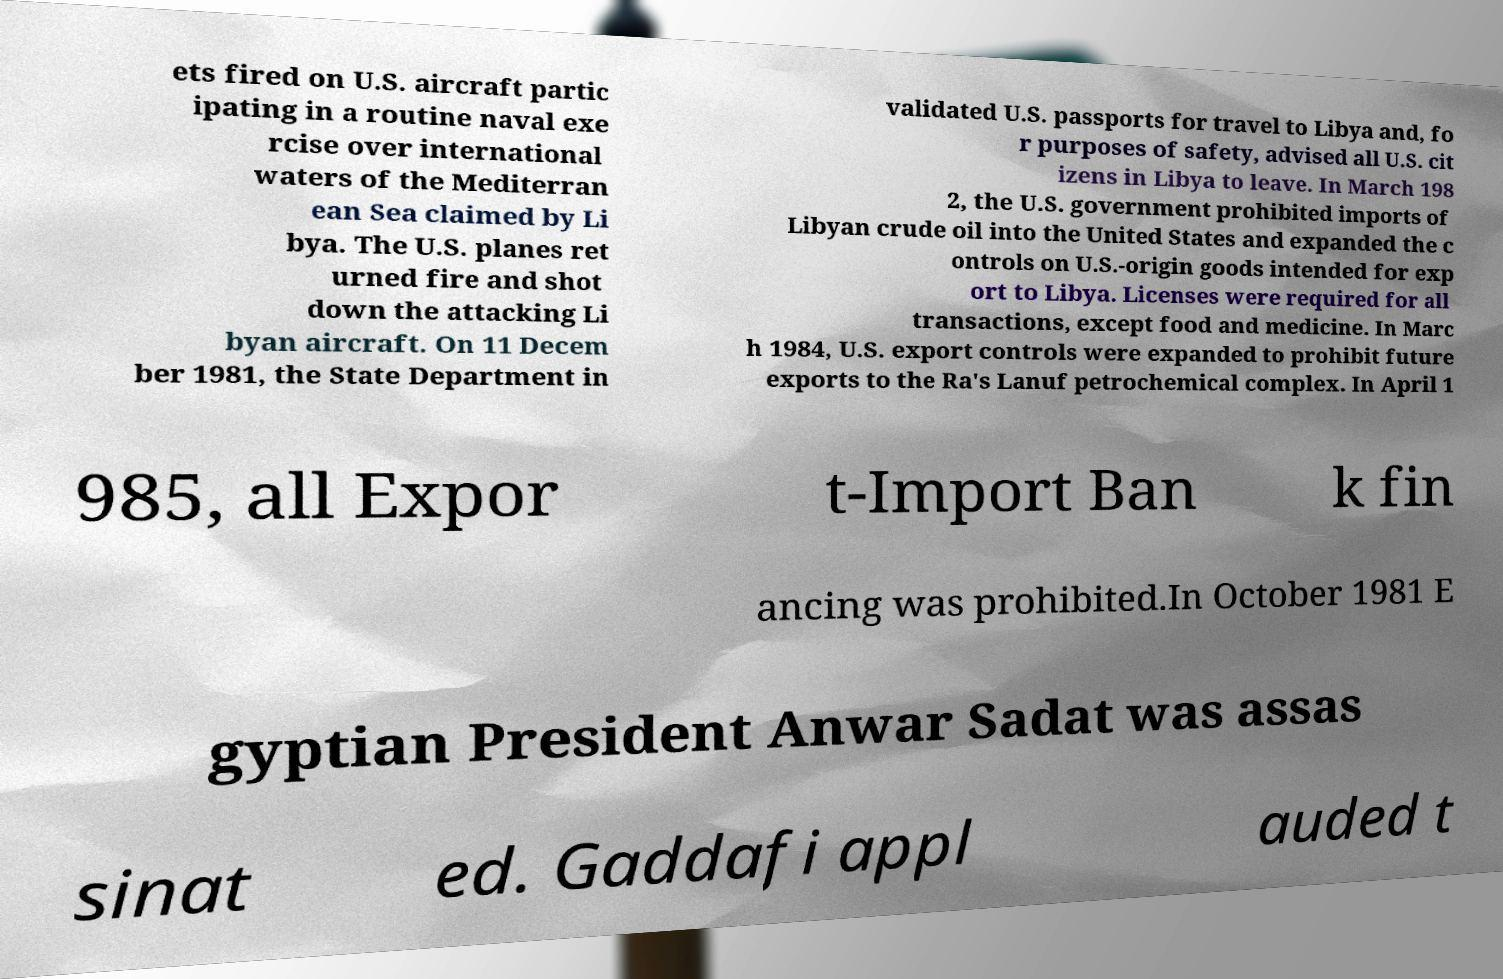Please read and relay the text visible in this image. What does it say? ets fired on U.S. aircraft partic ipating in a routine naval exe rcise over international waters of the Mediterran ean Sea claimed by Li bya. The U.S. planes ret urned fire and shot down the attacking Li byan aircraft. On 11 Decem ber 1981, the State Department in validated U.S. passports for travel to Libya and, fo r purposes of safety, advised all U.S. cit izens in Libya to leave. In March 198 2, the U.S. government prohibited imports of Libyan crude oil into the United States and expanded the c ontrols on U.S.-origin goods intended for exp ort to Libya. Licenses were required for all transactions, except food and medicine. In Marc h 1984, U.S. export controls were expanded to prohibit future exports to the Ra's Lanuf petrochemical complex. In April 1 985, all Expor t-Import Ban k fin ancing was prohibited.In October 1981 E gyptian President Anwar Sadat was assas sinat ed. Gaddafi appl auded t 